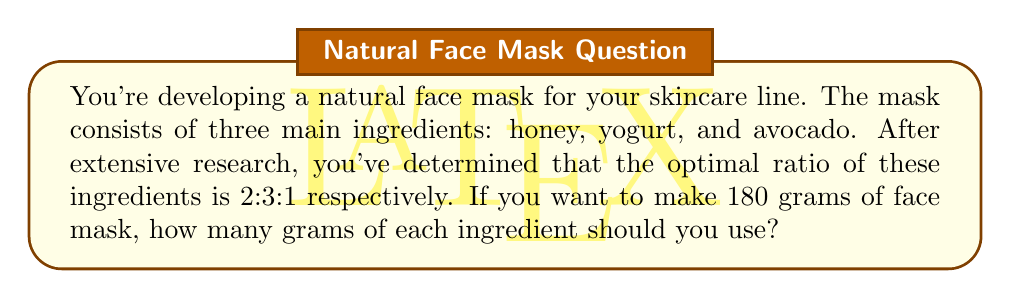Solve this math problem. Let's approach this step-by-step:

1) First, we need to understand what the ratio 2:3:1 means:
   - For every 2 parts of honey, we need 3 parts of yogurt and 1 part of avocado.
   - The total parts in the ratio is 2 + 3 + 1 = 6 parts.

2) We want to make 180 grams of face mask in total. So, we need to find out how much one "part" weighs:
   
   $$ \text{Weight of one part} = \frac{\text{Total weight}}{\text{Total parts}} = \frac{180}{6} = 30 \text{ grams} $$

3) Now that we know one part is 30 grams, we can calculate the weight of each ingredient:

   Honey: 2 parts = $2 \times 30 = 60$ grams
   Yogurt: 3 parts = $3 \times 30 = 90$ grams
   Avocado: 1 part = $1 \times 30 = 30$ grams

4) Let's verify that these add up to our total:

   $$ 60 + 90 + 30 = 180 \text{ grams} $$

   This confirms our calculations are correct.
Answer: For 180 grams of face mask:
Honey: 60 grams
Yogurt: 90 grams
Avocado: 30 grams 